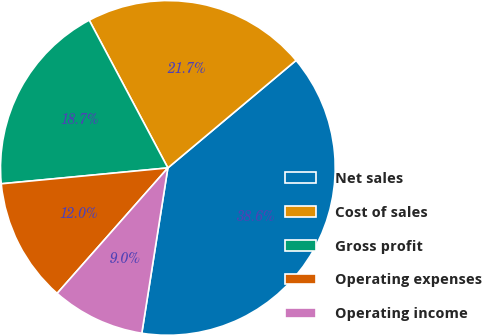<chart> <loc_0><loc_0><loc_500><loc_500><pie_chart><fcel>Net sales<fcel>Cost of sales<fcel>Gross profit<fcel>Operating expenses<fcel>Operating income<nl><fcel>38.6%<fcel>21.68%<fcel>18.73%<fcel>11.98%<fcel>9.02%<nl></chart> 